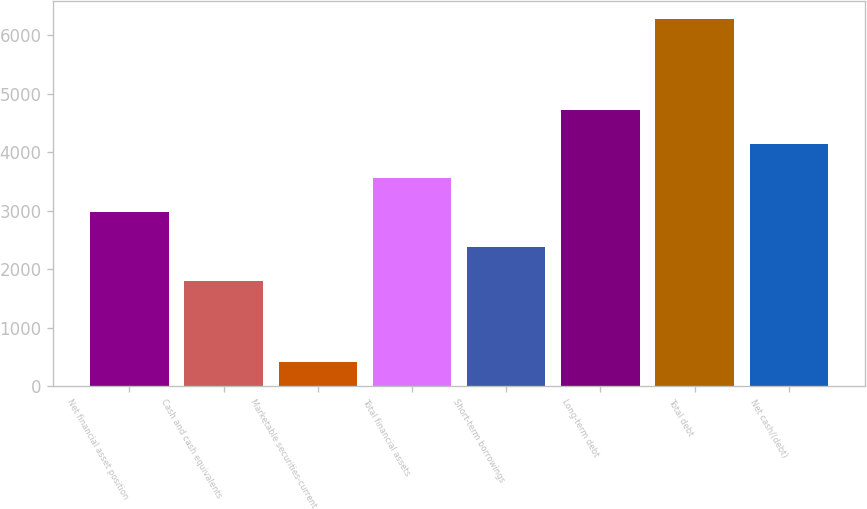Convert chart. <chart><loc_0><loc_0><loc_500><loc_500><bar_chart><fcel>Net financial asset position<fcel>Cash and cash equivalents<fcel>Marketable securities-current<fcel>Total financial assets<fcel>Short-term borrowings<fcel>Long-term debt<fcel>Total debt<fcel>Net cash/(debt)<nl><fcel>2970.6<fcel>1801<fcel>424<fcel>3555.4<fcel>2385.8<fcel>4725<fcel>6272<fcel>4140.2<nl></chart> 